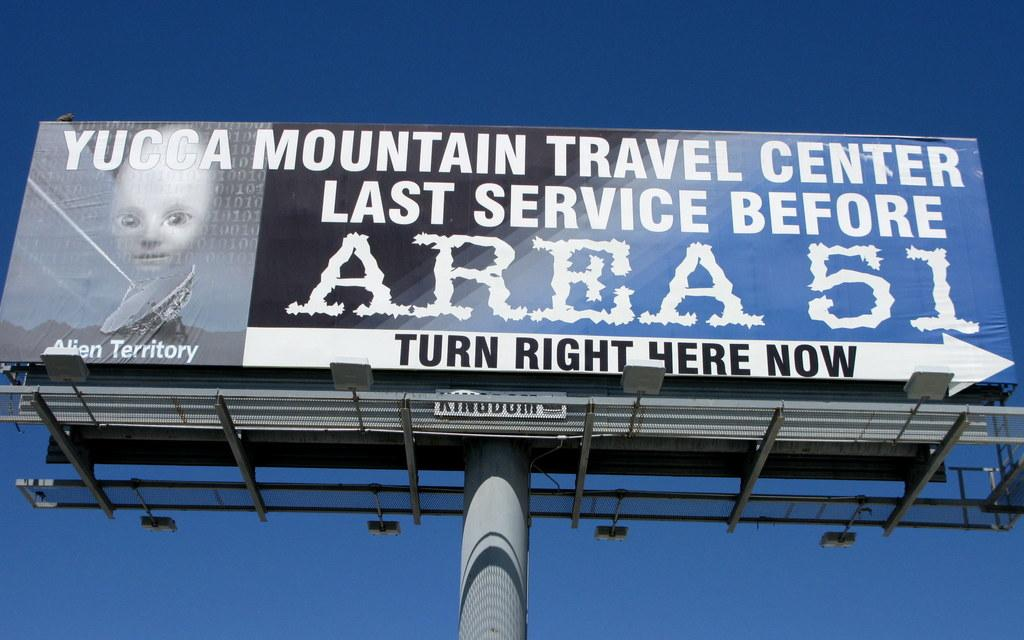<image>
Provide a brief description of the given image. A sign says to turn right here now and advertises Area 51. 